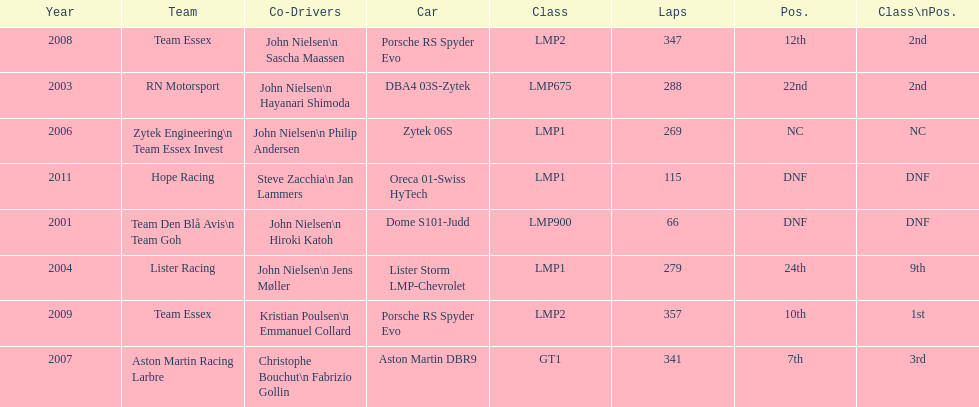Who were the co-drivers for the aston martin dbr9 in 2007? Christophe Bouchut, Fabrizio Gollin. 